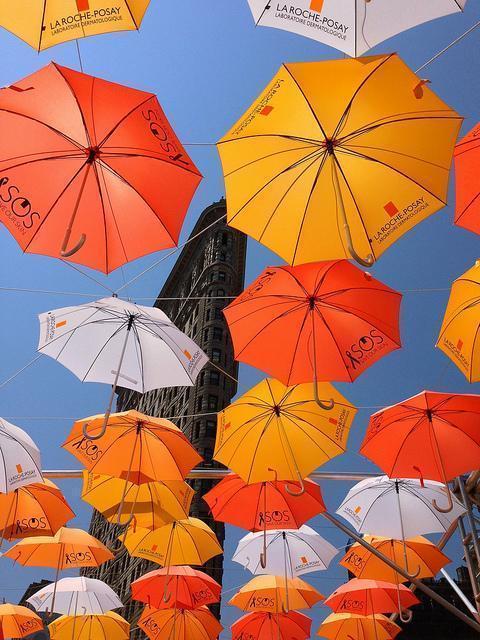What larger makeup group owns this company?
Pick the right solution, then justify: 'Answer: answer
Rationale: rationale.'
Options: Maybelline, cover girl, l'oreal, lancome. Answer: l'oreal.
Rationale: Logos are on a group of umbrellas. 